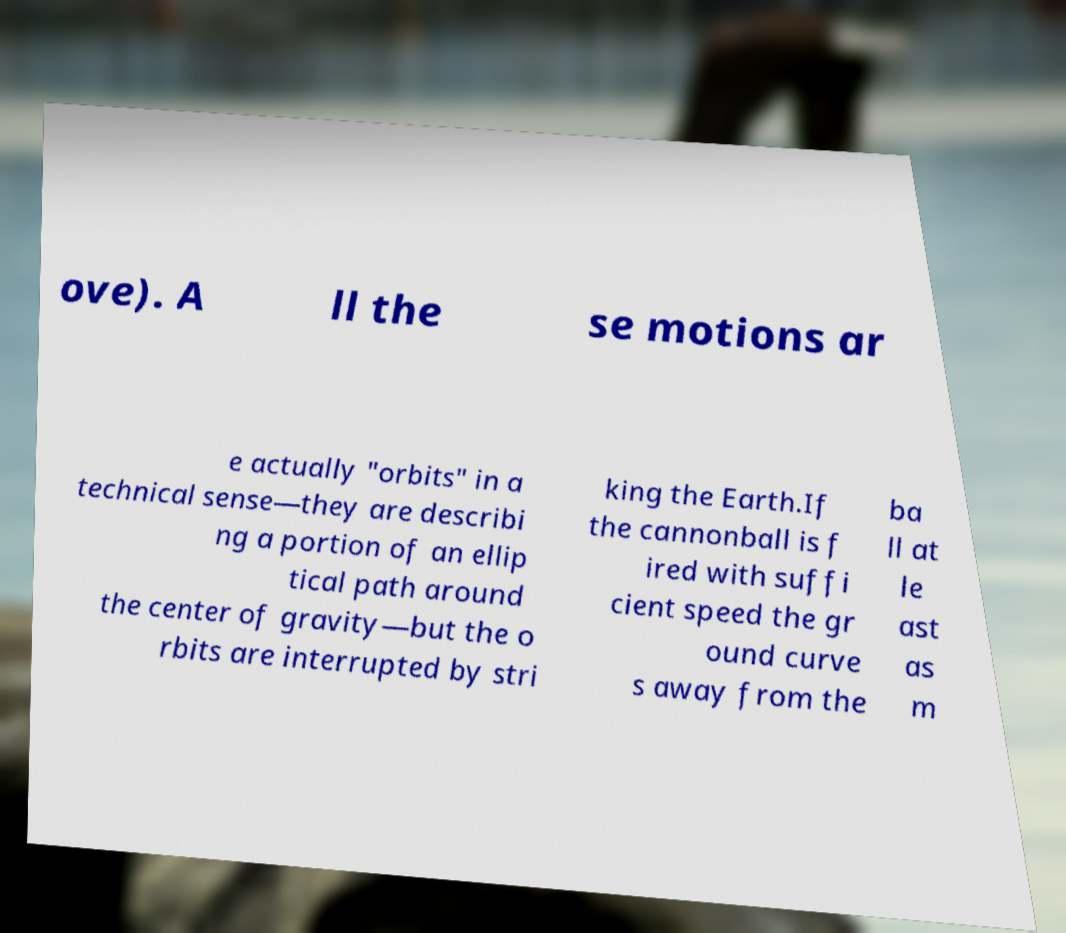For documentation purposes, I need the text within this image transcribed. Could you provide that? ove). A ll the se motions ar e actually "orbits" in a technical sense—they are describi ng a portion of an ellip tical path around the center of gravity—but the o rbits are interrupted by stri king the Earth.If the cannonball is f ired with suffi cient speed the gr ound curve s away from the ba ll at le ast as m 